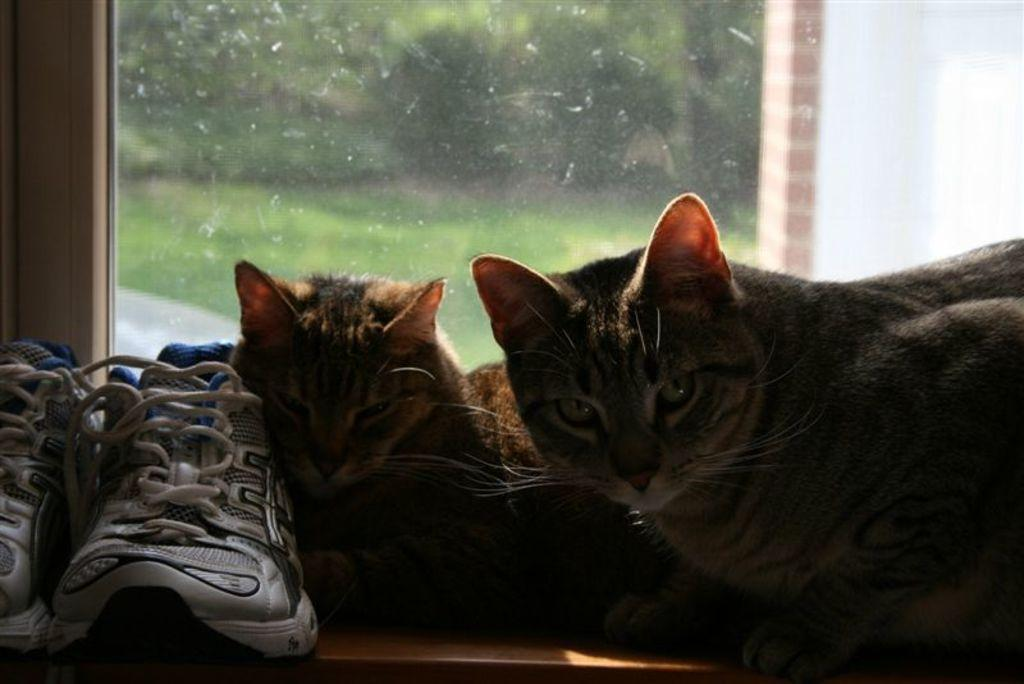What animals are sitting on the desk in the image? There are cats sitting on a desk in the image. What can be seen on the left side of the image? There are shoes on the left side of the image. What is visible in the background of the image? There is a window visible in the background of the image. What type of bread can be seen on the desk next to the cats? There is no bread present on the desk in the image; only cats are sitting on the desk. 